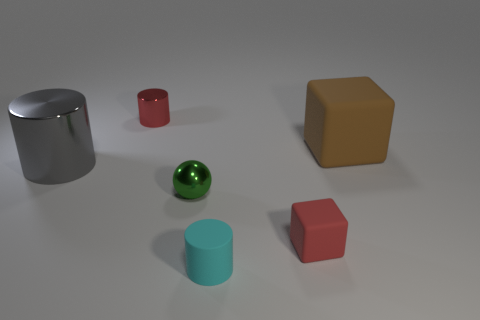Add 3 small metallic objects. How many objects exist? 9 Subtract all tiny metallic cylinders. How many cylinders are left? 2 Subtract 1 cylinders. How many cylinders are left? 2 Subtract all spheres. How many objects are left? 5 Add 1 small cyan metallic cylinders. How many small cyan metallic cylinders exist? 1 Subtract 1 brown blocks. How many objects are left? 5 Subtract all purple cubes. Subtract all gray spheres. How many cubes are left? 2 Subtract all small red metallic cylinders. Subtract all tiny shiny cylinders. How many objects are left? 4 Add 5 big metallic cylinders. How many big metallic cylinders are left? 6 